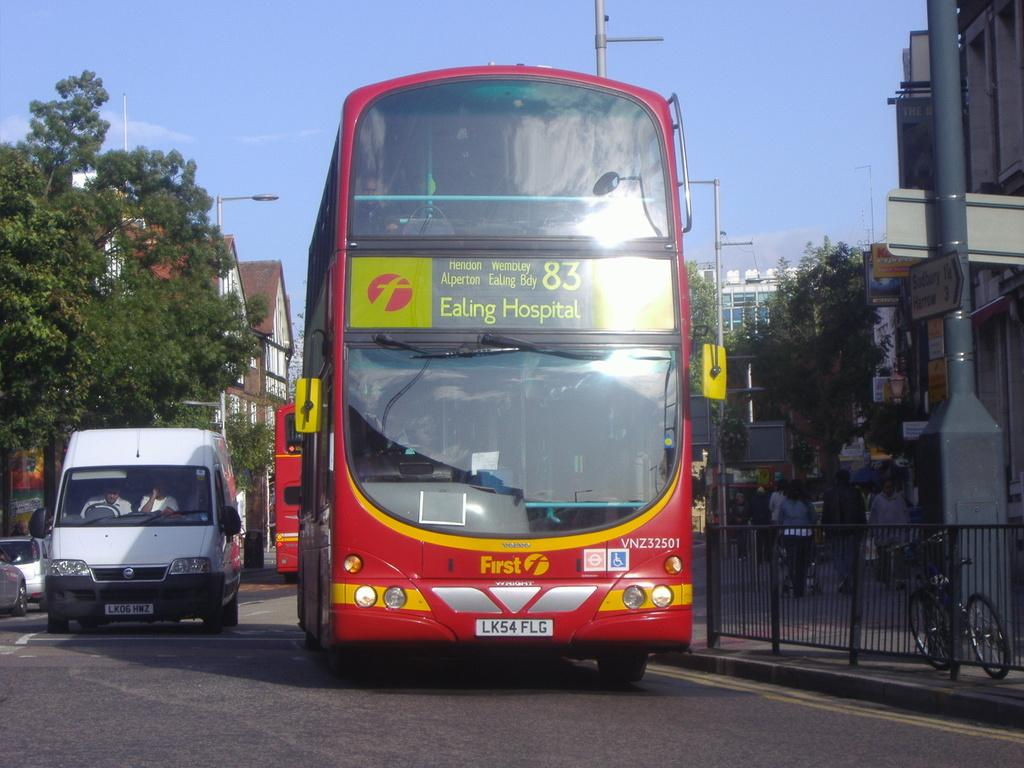<image>
Offer a succinct explanation of the picture presented. The number 83 bus to Ealing Hospital drives down a busy street. 